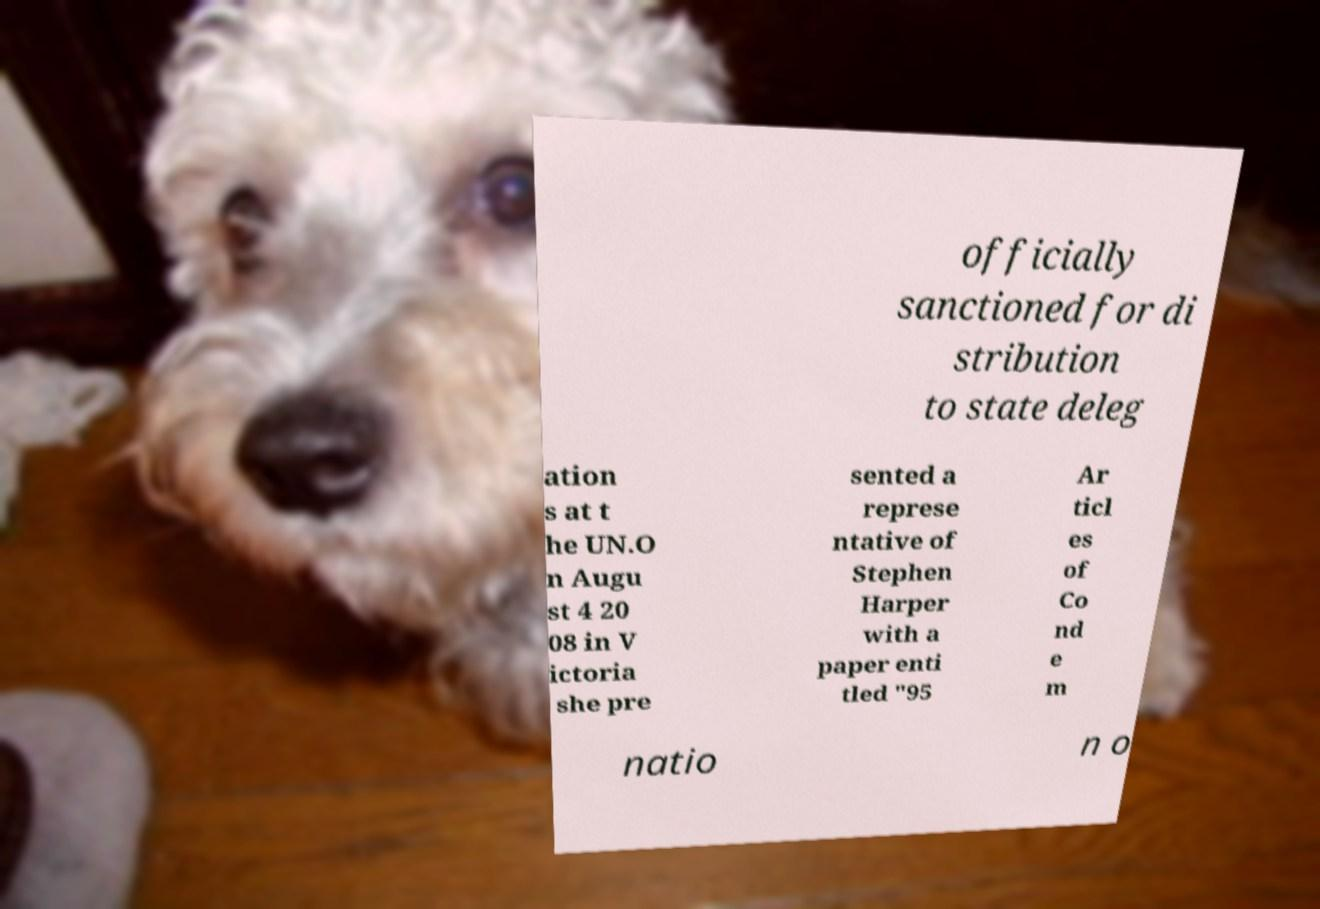What messages or text are displayed in this image? I need them in a readable, typed format. officially sanctioned for di stribution to state deleg ation s at t he UN.O n Augu st 4 20 08 in V ictoria she pre sented a represe ntative of Stephen Harper with a paper enti tled "95 Ar ticl es of Co nd e m natio n o 